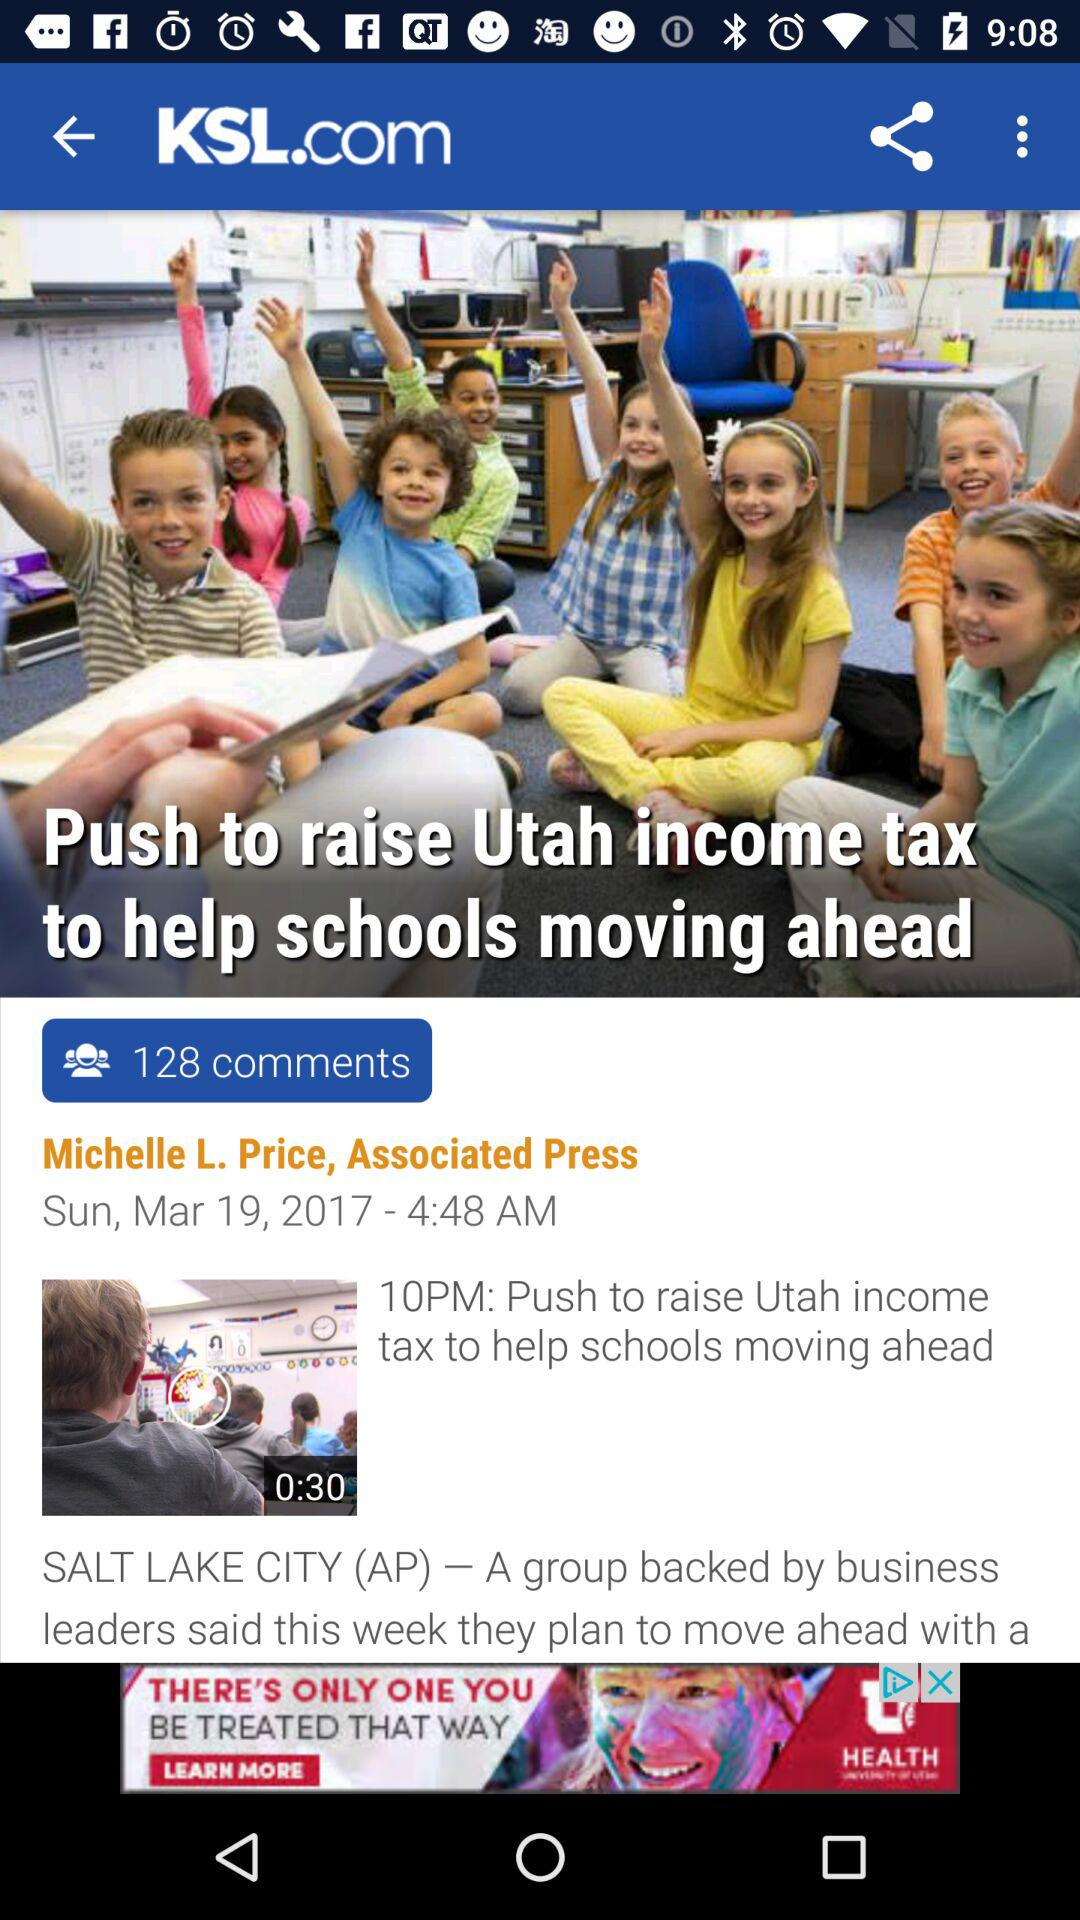What is the video length of "Push to raise Utah income tax help schools moving ahead"? The video length is 30 seconds. 